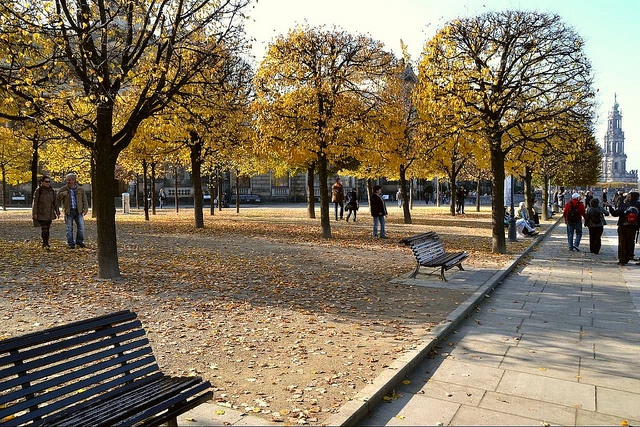Describe the objects in this image and their specific colors. I can see bench in olive, black, navy, gray, and darkgray tones, people in olive, black, gray, and darkgray tones, people in olive, black, and gray tones, bench in olive, black, gray, and darkgray tones, and people in olive, black, gray, maroon, and darkgray tones in this image. 